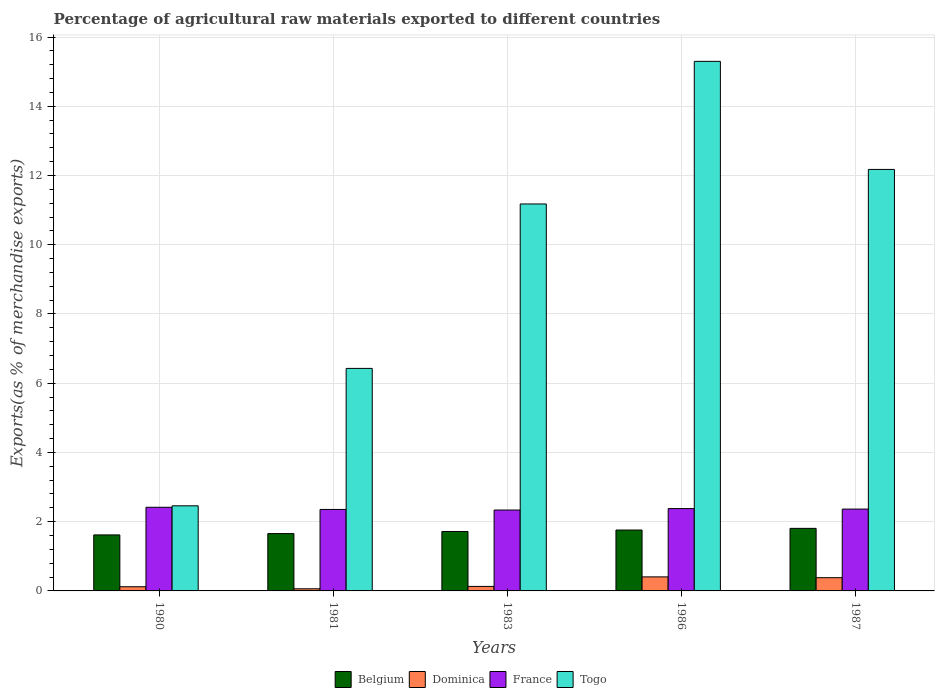How many different coloured bars are there?
Make the answer very short. 4. Are the number of bars per tick equal to the number of legend labels?
Offer a very short reply. Yes. How many bars are there on the 1st tick from the left?
Your response must be concise. 4. How many bars are there on the 3rd tick from the right?
Offer a very short reply. 4. What is the label of the 4th group of bars from the left?
Offer a very short reply. 1986. What is the percentage of exports to different countries in Belgium in 1983?
Your answer should be very brief. 1.72. Across all years, what is the maximum percentage of exports to different countries in Togo?
Keep it short and to the point. 15.3. Across all years, what is the minimum percentage of exports to different countries in Belgium?
Your answer should be very brief. 1.62. What is the total percentage of exports to different countries in France in the graph?
Keep it short and to the point. 11.85. What is the difference between the percentage of exports to different countries in Belgium in 1983 and that in 1987?
Offer a terse response. -0.09. What is the difference between the percentage of exports to different countries in France in 1981 and the percentage of exports to different countries in Belgium in 1987?
Keep it short and to the point. 0.55. What is the average percentage of exports to different countries in Belgium per year?
Make the answer very short. 1.71. In the year 1983, what is the difference between the percentage of exports to different countries in France and percentage of exports to different countries in Dominica?
Your answer should be very brief. 2.21. What is the ratio of the percentage of exports to different countries in Togo in 1980 to that in 1981?
Your answer should be compact. 0.38. What is the difference between the highest and the second highest percentage of exports to different countries in Dominica?
Your answer should be very brief. 0.02. What is the difference between the highest and the lowest percentage of exports to different countries in Togo?
Your answer should be very brief. 12.84. In how many years, is the percentage of exports to different countries in France greater than the average percentage of exports to different countries in France taken over all years?
Your answer should be very brief. 2. Is it the case that in every year, the sum of the percentage of exports to different countries in Togo and percentage of exports to different countries in Dominica is greater than the sum of percentage of exports to different countries in Belgium and percentage of exports to different countries in France?
Your response must be concise. Yes. What does the 4th bar from the left in 1986 represents?
Provide a short and direct response. Togo. How many bars are there?
Make the answer very short. 20. Are all the bars in the graph horizontal?
Offer a terse response. No. What is the difference between two consecutive major ticks on the Y-axis?
Provide a succinct answer. 2. Are the values on the major ticks of Y-axis written in scientific E-notation?
Offer a very short reply. No. Does the graph contain any zero values?
Ensure brevity in your answer.  No. Does the graph contain grids?
Make the answer very short. Yes. Where does the legend appear in the graph?
Keep it short and to the point. Bottom center. How are the legend labels stacked?
Provide a short and direct response. Horizontal. What is the title of the graph?
Your answer should be compact. Percentage of agricultural raw materials exported to different countries. Does "Other small states" appear as one of the legend labels in the graph?
Ensure brevity in your answer.  No. What is the label or title of the Y-axis?
Offer a terse response. Exports(as % of merchandise exports). What is the Exports(as % of merchandise exports) in Belgium in 1980?
Keep it short and to the point. 1.62. What is the Exports(as % of merchandise exports) of Dominica in 1980?
Offer a terse response. 0.12. What is the Exports(as % of merchandise exports) in France in 1980?
Your answer should be compact. 2.42. What is the Exports(as % of merchandise exports) in Togo in 1980?
Your answer should be compact. 2.46. What is the Exports(as % of merchandise exports) of Belgium in 1981?
Give a very brief answer. 1.66. What is the Exports(as % of merchandise exports) of Dominica in 1981?
Your response must be concise. 0.06. What is the Exports(as % of merchandise exports) of France in 1981?
Give a very brief answer. 2.35. What is the Exports(as % of merchandise exports) in Togo in 1981?
Ensure brevity in your answer.  6.43. What is the Exports(as % of merchandise exports) of Belgium in 1983?
Keep it short and to the point. 1.72. What is the Exports(as % of merchandise exports) of Dominica in 1983?
Make the answer very short. 0.13. What is the Exports(as % of merchandise exports) of France in 1983?
Your answer should be compact. 2.34. What is the Exports(as % of merchandise exports) in Togo in 1983?
Provide a succinct answer. 11.18. What is the Exports(as % of merchandise exports) in Belgium in 1986?
Your answer should be compact. 1.76. What is the Exports(as % of merchandise exports) in Dominica in 1986?
Make the answer very short. 0.41. What is the Exports(as % of merchandise exports) of France in 1986?
Your response must be concise. 2.38. What is the Exports(as % of merchandise exports) of Togo in 1986?
Offer a terse response. 15.3. What is the Exports(as % of merchandise exports) in Belgium in 1987?
Your answer should be very brief. 1.81. What is the Exports(as % of merchandise exports) in Dominica in 1987?
Your response must be concise. 0.38. What is the Exports(as % of merchandise exports) of France in 1987?
Your response must be concise. 2.36. What is the Exports(as % of merchandise exports) of Togo in 1987?
Make the answer very short. 12.18. Across all years, what is the maximum Exports(as % of merchandise exports) in Belgium?
Your answer should be compact. 1.81. Across all years, what is the maximum Exports(as % of merchandise exports) of Dominica?
Offer a terse response. 0.41. Across all years, what is the maximum Exports(as % of merchandise exports) in France?
Make the answer very short. 2.42. Across all years, what is the maximum Exports(as % of merchandise exports) in Togo?
Your response must be concise. 15.3. Across all years, what is the minimum Exports(as % of merchandise exports) in Belgium?
Give a very brief answer. 1.62. Across all years, what is the minimum Exports(as % of merchandise exports) of Dominica?
Your answer should be very brief. 0.06. Across all years, what is the minimum Exports(as % of merchandise exports) in France?
Your answer should be compact. 2.34. Across all years, what is the minimum Exports(as % of merchandise exports) of Togo?
Your answer should be compact. 2.46. What is the total Exports(as % of merchandise exports) of Belgium in the graph?
Provide a short and direct response. 8.56. What is the total Exports(as % of merchandise exports) in Dominica in the graph?
Keep it short and to the point. 1.1. What is the total Exports(as % of merchandise exports) in France in the graph?
Provide a succinct answer. 11.85. What is the total Exports(as % of merchandise exports) in Togo in the graph?
Make the answer very short. 47.54. What is the difference between the Exports(as % of merchandise exports) in Belgium in 1980 and that in 1981?
Make the answer very short. -0.04. What is the difference between the Exports(as % of merchandise exports) in Dominica in 1980 and that in 1981?
Offer a terse response. 0.06. What is the difference between the Exports(as % of merchandise exports) in France in 1980 and that in 1981?
Offer a very short reply. 0.06. What is the difference between the Exports(as % of merchandise exports) of Togo in 1980 and that in 1981?
Your answer should be compact. -3.97. What is the difference between the Exports(as % of merchandise exports) in Belgium in 1980 and that in 1983?
Give a very brief answer. -0.1. What is the difference between the Exports(as % of merchandise exports) of Dominica in 1980 and that in 1983?
Your answer should be compact. -0.01. What is the difference between the Exports(as % of merchandise exports) of Togo in 1980 and that in 1983?
Give a very brief answer. -8.72. What is the difference between the Exports(as % of merchandise exports) in Belgium in 1980 and that in 1986?
Ensure brevity in your answer.  -0.14. What is the difference between the Exports(as % of merchandise exports) of Dominica in 1980 and that in 1986?
Offer a very short reply. -0.29. What is the difference between the Exports(as % of merchandise exports) of France in 1980 and that in 1986?
Keep it short and to the point. 0.04. What is the difference between the Exports(as % of merchandise exports) of Togo in 1980 and that in 1986?
Ensure brevity in your answer.  -12.84. What is the difference between the Exports(as % of merchandise exports) of Belgium in 1980 and that in 1987?
Provide a succinct answer. -0.19. What is the difference between the Exports(as % of merchandise exports) of Dominica in 1980 and that in 1987?
Offer a terse response. -0.26. What is the difference between the Exports(as % of merchandise exports) of France in 1980 and that in 1987?
Provide a short and direct response. 0.05. What is the difference between the Exports(as % of merchandise exports) of Togo in 1980 and that in 1987?
Provide a succinct answer. -9.72. What is the difference between the Exports(as % of merchandise exports) of Belgium in 1981 and that in 1983?
Provide a short and direct response. -0.06. What is the difference between the Exports(as % of merchandise exports) of Dominica in 1981 and that in 1983?
Offer a terse response. -0.07. What is the difference between the Exports(as % of merchandise exports) of France in 1981 and that in 1983?
Offer a terse response. 0.02. What is the difference between the Exports(as % of merchandise exports) in Togo in 1981 and that in 1983?
Your answer should be compact. -4.75. What is the difference between the Exports(as % of merchandise exports) of Belgium in 1981 and that in 1986?
Ensure brevity in your answer.  -0.1. What is the difference between the Exports(as % of merchandise exports) of Dominica in 1981 and that in 1986?
Keep it short and to the point. -0.34. What is the difference between the Exports(as % of merchandise exports) of France in 1981 and that in 1986?
Ensure brevity in your answer.  -0.02. What is the difference between the Exports(as % of merchandise exports) of Togo in 1981 and that in 1986?
Provide a succinct answer. -8.87. What is the difference between the Exports(as % of merchandise exports) in Belgium in 1981 and that in 1987?
Provide a short and direct response. -0.15. What is the difference between the Exports(as % of merchandise exports) in Dominica in 1981 and that in 1987?
Your answer should be compact. -0.32. What is the difference between the Exports(as % of merchandise exports) of France in 1981 and that in 1987?
Offer a very short reply. -0.01. What is the difference between the Exports(as % of merchandise exports) in Togo in 1981 and that in 1987?
Make the answer very short. -5.75. What is the difference between the Exports(as % of merchandise exports) of Belgium in 1983 and that in 1986?
Keep it short and to the point. -0.04. What is the difference between the Exports(as % of merchandise exports) in Dominica in 1983 and that in 1986?
Provide a succinct answer. -0.28. What is the difference between the Exports(as % of merchandise exports) of France in 1983 and that in 1986?
Make the answer very short. -0.04. What is the difference between the Exports(as % of merchandise exports) in Togo in 1983 and that in 1986?
Offer a terse response. -4.12. What is the difference between the Exports(as % of merchandise exports) in Belgium in 1983 and that in 1987?
Offer a very short reply. -0.09. What is the difference between the Exports(as % of merchandise exports) of Dominica in 1983 and that in 1987?
Provide a short and direct response. -0.25. What is the difference between the Exports(as % of merchandise exports) in France in 1983 and that in 1987?
Give a very brief answer. -0.03. What is the difference between the Exports(as % of merchandise exports) of Togo in 1983 and that in 1987?
Your answer should be compact. -1. What is the difference between the Exports(as % of merchandise exports) in Belgium in 1986 and that in 1987?
Offer a very short reply. -0.05. What is the difference between the Exports(as % of merchandise exports) of Dominica in 1986 and that in 1987?
Offer a very short reply. 0.02. What is the difference between the Exports(as % of merchandise exports) in France in 1986 and that in 1987?
Ensure brevity in your answer.  0.01. What is the difference between the Exports(as % of merchandise exports) in Togo in 1986 and that in 1987?
Offer a terse response. 3.12. What is the difference between the Exports(as % of merchandise exports) of Belgium in 1980 and the Exports(as % of merchandise exports) of Dominica in 1981?
Your response must be concise. 1.56. What is the difference between the Exports(as % of merchandise exports) in Belgium in 1980 and the Exports(as % of merchandise exports) in France in 1981?
Ensure brevity in your answer.  -0.74. What is the difference between the Exports(as % of merchandise exports) in Belgium in 1980 and the Exports(as % of merchandise exports) in Togo in 1981?
Offer a very short reply. -4.81. What is the difference between the Exports(as % of merchandise exports) in Dominica in 1980 and the Exports(as % of merchandise exports) in France in 1981?
Your response must be concise. -2.23. What is the difference between the Exports(as % of merchandise exports) in Dominica in 1980 and the Exports(as % of merchandise exports) in Togo in 1981?
Your response must be concise. -6.31. What is the difference between the Exports(as % of merchandise exports) in France in 1980 and the Exports(as % of merchandise exports) in Togo in 1981?
Ensure brevity in your answer.  -4.01. What is the difference between the Exports(as % of merchandise exports) of Belgium in 1980 and the Exports(as % of merchandise exports) of Dominica in 1983?
Provide a succinct answer. 1.49. What is the difference between the Exports(as % of merchandise exports) of Belgium in 1980 and the Exports(as % of merchandise exports) of France in 1983?
Make the answer very short. -0.72. What is the difference between the Exports(as % of merchandise exports) in Belgium in 1980 and the Exports(as % of merchandise exports) in Togo in 1983?
Give a very brief answer. -9.56. What is the difference between the Exports(as % of merchandise exports) in Dominica in 1980 and the Exports(as % of merchandise exports) in France in 1983?
Ensure brevity in your answer.  -2.22. What is the difference between the Exports(as % of merchandise exports) in Dominica in 1980 and the Exports(as % of merchandise exports) in Togo in 1983?
Your answer should be very brief. -11.06. What is the difference between the Exports(as % of merchandise exports) in France in 1980 and the Exports(as % of merchandise exports) in Togo in 1983?
Your response must be concise. -8.76. What is the difference between the Exports(as % of merchandise exports) in Belgium in 1980 and the Exports(as % of merchandise exports) in Dominica in 1986?
Provide a succinct answer. 1.21. What is the difference between the Exports(as % of merchandise exports) in Belgium in 1980 and the Exports(as % of merchandise exports) in France in 1986?
Keep it short and to the point. -0.76. What is the difference between the Exports(as % of merchandise exports) in Belgium in 1980 and the Exports(as % of merchandise exports) in Togo in 1986?
Your answer should be very brief. -13.68. What is the difference between the Exports(as % of merchandise exports) in Dominica in 1980 and the Exports(as % of merchandise exports) in France in 1986?
Your response must be concise. -2.26. What is the difference between the Exports(as % of merchandise exports) of Dominica in 1980 and the Exports(as % of merchandise exports) of Togo in 1986?
Make the answer very short. -15.18. What is the difference between the Exports(as % of merchandise exports) of France in 1980 and the Exports(as % of merchandise exports) of Togo in 1986?
Offer a very short reply. -12.88. What is the difference between the Exports(as % of merchandise exports) of Belgium in 1980 and the Exports(as % of merchandise exports) of Dominica in 1987?
Keep it short and to the point. 1.24. What is the difference between the Exports(as % of merchandise exports) in Belgium in 1980 and the Exports(as % of merchandise exports) in France in 1987?
Ensure brevity in your answer.  -0.75. What is the difference between the Exports(as % of merchandise exports) in Belgium in 1980 and the Exports(as % of merchandise exports) in Togo in 1987?
Ensure brevity in your answer.  -10.56. What is the difference between the Exports(as % of merchandise exports) of Dominica in 1980 and the Exports(as % of merchandise exports) of France in 1987?
Give a very brief answer. -2.24. What is the difference between the Exports(as % of merchandise exports) of Dominica in 1980 and the Exports(as % of merchandise exports) of Togo in 1987?
Your answer should be compact. -12.05. What is the difference between the Exports(as % of merchandise exports) in France in 1980 and the Exports(as % of merchandise exports) in Togo in 1987?
Keep it short and to the point. -9.76. What is the difference between the Exports(as % of merchandise exports) in Belgium in 1981 and the Exports(as % of merchandise exports) in Dominica in 1983?
Provide a short and direct response. 1.53. What is the difference between the Exports(as % of merchandise exports) in Belgium in 1981 and the Exports(as % of merchandise exports) in France in 1983?
Offer a terse response. -0.68. What is the difference between the Exports(as % of merchandise exports) in Belgium in 1981 and the Exports(as % of merchandise exports) in Togo in 1983?
Offer a very short reply. -9.52. What is the difference between the Exports(as % of merchandise exports) in Dominica in 1981 and the Exports(as % of merchandise exports) in France in 1983?
Your answer should be compact. -2.28. What is the difference between the Exports(as % of merchandise exports) in Dominica in 1981 and the Exports(as % of merchandise exports) in Togo in 1983?
Offer a terse response. -11.12. What is the difference between the Exports(as % of merchandise exports) of France in 1981 and the Exports(as % of merchandise exports) of Togo in 1983?
Provide a succinct answer. -8.82. What is the difference between the Exports(as % of merchandise exports) of Belgium in 1981 and the Exports(as % of merchandise exports) of Dominica in 1986?
Give a very brief answer. 1.25. What is the difference between the Exports(as % of merchandise exports) in Belgium in 1981 and the Exports(as % of merchandise exports) in France in 1986?
Make the answer very short. -0.72. What is the difference between the Exports(as % of merchandise exports) of Belgium in 1981 and the Exports(as % of merchandise exports) of Togo in 1986?
Give a very brief answer. -13.64. What is the difference between the Exports(as % of merchandise exports) in Dominica in 1981 and the Exports(as % of merchandise exports) in France in 1986?
Keep it short and to the point. -2.32. What is the difference between the Exports(as % of merchandise exports) in Dominica in 1981 and the Exports(as % of merchandise exports) in Togo in 1986?
Provide a short and direct response. -15.24. What is the difference between the Exports(as % of merchandise exports) of France in 1981 and the Exports(as % of merchandise exports) of Togo in 1986?
Ensure brevity in your answer.  -12.94. What is the difference between the Exports(as % of merchandise exports) in Belgium in 1981 and the Exports(as % of merchandise exports) in Dominica in 1987?
Offer a terse response. 1.27. What is the difference between the Exports(as % of merchandise exports) of Belgium in 1981 and the Exports(as % of merchandise exports) of France in 1987?
Your response must be concise. -0.71. What is the difference between the Exports(as % of merchandise exports) of Belgium in 1981 and the Exports(as % of merchandise exports) of Togo in 1987?
Give a very brief answer. -10.52. What is the difference between the Exports(as % of merchandise exports) of Dominica in 1981 and the Exports(as % of merchandise exports) of France in 1987?
Your response must be concise. -2.3. What is the difference between the Exports(as % of merchandise exports) of Dominica in 1981 and the Exports(as % of merchandise exports) of Togo in 1987?
Keep it short and to the point. -12.11. What is the difference between the Exports(as % of merchandise exports) of France in 1981 and the Exports(as % of merchandise exports) of Togo in 1987?
Provide a short and direct response. -9.82. What is the difference between the Exports(as % of merchandise exports) in Belgium in 1983 and the Exports(as % of merchandise exports) in Dominica in 1986?
Make the answer very short. 1.31. What is the difference between the Exports(as % of merchandise exports) in Belgium in 1983 and the Exports(as % of merchandise exports) in France in 1986?
Provide a short and direct response. -0.66. What is the difference between the Exports(as % of merchandise exports) of Belgium in 1983 and the Exports(as % of merchandise exports) of Togo in 1986?
Your answer should be very brief. -13.58. What is the difference between the Exports(as % of merchandise exports) in Dominica in 1983 and the Exports(as % of merchandise exports) in France in 1986?
Make the answer very short. -2.25. What is the difference between the Exports(as % of merchandise exports) in Dominica in 1983 and the Exports(as % of merchandise exports) in Togo in 1986?
Offer a very short reply. -15.17. What is the difference between the Exports(as % of merchandise exports) in France in 1983 and the Exports(as % of merchandise exports) in Togo in 1986?
Keep it short and to the point. -12.96. What is the difference between the Exports(as % of merchandise exports) in Belgium in 1983 and the Exports(as % of merchandise exports) in Dominica in 1987?
Offer a terse response. 1.33. What is the difference between the Exports(as % of merchandise exports) in Belgium in 1983 and the Exports(as % of merchandise exports) in France in 1987?
Keep it short and to the point. -0.65. What is the difference between the Exports(as % of merchandise exports) in Belgium in 1983 and the Exports(as % of merchandise exports) in Togo in 1987?
Your answer should be compact. -10.46. What is the difference between the Exports(as % of merchandise exports) of Dominica in 1983 and the Exports(as % of merchandise exports) of France in 1987?
Give a very brief answer. -2.23. What is the difference between the Exports(as % of merchandise exports) in Dominica in 1983 and the Exports(as % of merchandise exports) in Togo in 1987?
Give a very brief answer. -12.05. What is the difference between the Exports(as % of merchandise exports) of France in 1983 and the Exports(as % of merchandise exports) of Togo in 1987?
Your answer should be very brief. -9.84. What is the difference between the Exports(as % of merchandise exports) in Belgium in 1986 and the Exports(as % of merchandise exports) in Dominica in 1987?
Offer a terse response. 1.38. What is the difference between the Exports(as % of merchandise exports) in Belgium in 1986 and the Exports(as % of merchandise exports) in France in 1987?
Keep it short and to the point. -0.61. What is the difference between the Exports(as % of merchandise exports) of Belgium in 1986 and the Exports(as % of merchandise exports) of Togo in 1987?
Your answer should be very brief. -10.42. What is the difference between the Exports(as % of merchandise exports) in Dominica in 1986 and the Exports(as % of merchandise exports) in France in 1987?
Ensure brevity in your answer.  -1.96. What is the difference between the Exports(as % of merchandise exports) of Dominica in 1986 and the Exports(as % of merchandise exports) of Togo in 1987?
Give a very brief answer. -11.77. What is the difference between the Exports(as % of merchandise exports) of France in 1986 and the Exports(as % of merchandise exports) of Togo in 1987?
Offer a very short reply. -9.8. What is the average Exports(as % of merchandise exports) in Belgium per year?
Keep it short and to the point. 1.71. What is the average Exports(as % of merchandise exports) of Dominica per year?
Make the answer very short. 0.22. What is the average Exports(as % of merchandise exports) of France per year?
Keep it short and to the point. 2.37. What is the average Exports(as % of merchandise exports) in Togo per year?
Offer a terse response. 9.51. In the year 1980, what is the difference between the Exports(as % of merchandise exports) in Belgium and Exports(as % of merchandise exports) in Dominica?
Make the answer very short. 1.5. In the year 1980, what is the difference between the Exports(as % of merchandise exports) of Belgium and Exports(as % of merchandise exports) of France?
Offer a very short reply. -0.8. In the year 1980, what is the difference between the Exports(as % of merchandise exports) in Belgium and Exports(as % of merchandise exports) in Togo?
Your response must be concise. -0.84. In the year 1980, what is the difference between the Exports(as % of merchandise exports) of Dominica and Exports(as % of merchandise exports) of France?
Provide a short and direct response. -2.3. In the year 1980, what is the difference between the Exports(as % of merchandise exports) in Dominica and Exports(as % of merchandise exports) in Togo?
Keep it short and to the point. -2.34. In the year 1980, what is the difference between the Exports(as % of merchandise exports) in France and Exports(as % of merchandise exports) in Togo?
Offer a very short reply. -0.04. In the year 1981, what is the difference between the Exports(as % of merchandise exports) in Belgium and Exports(as % of merchandise exports) in Dominica?
Keep it short and to the point. 1.59. In the year 1981, what is the difference between the Exports(as % of merchandise exports) of Belgium and Exports(as % of merchandise exports) of France?
Offer a very short reply. -0.7. In the year 1981, what is the difference between the Exports(as % of merchandise exports) of Belgium and Exports(as % of merchandise exports) of Togo?
Make the answer very short. -4.77. In the year 1981, what is the difference between the Exports(as % of merchandise exports) in Dominica and Exports(as % of merchandise exports) in France?
Your answer should be very brief. -2.29. In the year 1981, what is the difference between the Exports(as % of merchandise exports) in Dominica and Exports(as % of merchandise exports) in Togo?
Your response must be concise. -6.37. In the year 1981, what is the difference between the Exports(as % of merchandise exports) of France and Exports(as % of merchandise exports) of Togo?
Provide a short and direct response. -4.07. In the year 1983, what is the difference between the Exports(as % of merchandise exports) in Belgium and Exports(as % of merchandise exports) in Dominica?
Provide a succinct answer. 1.59. In the year 1983, what is the difference between the Exports(as % of merchandise exports) of Belgium and Exports(as % of merchandise exports) of France?
Offer a very short reply. -0.62. In the year 1983, what is the difference between the Exports(as % of merchandise exports) of Belgium and Exports(as % of merchandise exports) of Togo?
Offer a very short reply. -9.46. In the year 1983, what is the difference between the Exports(as % of merchandise exports) in Dominica and Exports(as % of merchandise exports) in France?
Provide a succinct answer. -2.21. In the year 1983, what is the difference between the Exports(as % of merchandise exports) in Dominica and Exports(as % of merchandise exports) in Togo?
Offer a terse response. -11.05. In the year 1983, what is the difference between the Exports(as % of merchandise exports) in France and Exports(as % of merchandise exports) in Togo?
Make the answer very short. -8.84. In the year 1986, what is the difference between the Exports(as % of merchandise exports) in Belgium and Exports(as % of merchandise exports) in Dominica?
Provide a short and direct response. 1.35. In the year 1986, what is the difference between the Exports(as % of merchandise exports) of Belgium and Exports(as % of merchandise exports) of France?
Provide a succinct answer. -0.62. In the year 1986, what is the difference between the Exports(as % of merchandise exports) in Belgium and Exports(as % of merchandise exports) in Togo?
Provide a short and direct response. -13.54. In the year 1986, what is the difference between the Exports(as % of merchandise exports) of Dominica and Exports(as % of merchandise exports) of France?
Your response must be concise. -1.97. In the year 1986, what is the difference between the Exports(as % of merchandise exports) in Dominica and Exports(as % of merchandise exports) in Togo?
Offer a very short reply. -14.89. In the year 1986, what is the difference between the Exports(as % of merchandise exports) of France and Exports(as % of merchandise exports) of Togo?
Ensure brevity in your answer.  -12.92. In the year 1987, what is the difference between the Exports(as % of merchandise exports) of Belgium and Exports(as % of merchandise exports) of Dominica?
Provide a succinct answer. 1.43. In the year 1987, what is the difference between the Exports(as % of merchandise exports) in Belgium and Exports(as % of merchandise exports) in France?
Provide a succinct answer. -0.56. In the year 1987, what is the difference between the Exports(as % of merchandise exports) of Belgium and Exports(as % of merchandise exports) of Togo?
Your answer should be compact. -10.37. In the year 1987, what is the difference between the Exports(as % of merchandise exports) of Dominica and Exports(as % of merchandise exports) of France?
Give a very brief answer. -1.98. In the year 1987, what is the difference between the Exports(as % of merchandise exports) of Dominica and Exports(as % of merchandise exports) of Togo?
Your answer should be very brief. -11.79. In the year 1987, what is the difference between the Exports(as % of merchandise exports) of France and Exports(as % of merchandise exports) of Togo?
Your answer should be compact. -9.81. What is the ratio of the Exports(as % of merchandise exports) of Belgium in 1980 to that in 1981?
Give a very brief answer. 0.98. What is the ratio of the Exports(as % of merchandise exports) in Dominica in 1980 to that in 1981?
Provide a short and direct response. 1.96. What is the ratio of the Exports(as % of merchandise exports) of France in 1980 to that in 1981?
Your response must be concise. 1.03. What is the ratio of the Exports(as % of merchandise exports) of Togo in 1980 to that in 1981?
Make the answer very short. 0.38. What is the ratio of the Exports(as % of merchandise exports) in Belgium in 1980 to that in 1983?
Offer a terse response. 0.94. What is the ratio of the Exports(as % of merchandise exports) of Dominica in 1980 to that in 1983?
Provide a short and direct response. 0.93. What is the ratio of the Exports(as % of merchandise exports) of France in 1980 to that in 1983?
Make the answer very short. 1.03. What is the ratio of the Exports(as % of merchandise exports) of Togo in 1980 to that in 1983?
Give a very brief answer. 0.22. What is the ratio of the Exports(as % of merchandise exports) of Belgium in 1980 to that in 1986?
Your response must be concise. 0.92. What is the ratio of the Exports(as % of merchandise exports) in Dominica in 1980 to that in 1986?
Give a very brief answer. 0.3. What is the ratio of the Exports(as % of merchandise exports) of France in 1980 to that in 1986?
Ensure brevity in your answer.  1.02. What is the ratio of the Exports(as % of merchandise exports) in Togo in 1980 to that in 1986?
Your answer should be compact. 0.16. What is the ratio of the Exports(as % of merchandise exports) in Belgium in 1980 to that in 1987?
Offer a terse response. 0.9. What is the ratio of the Exports(as % of merchandise exports) of Dominica in 1980 to that in 1987?
Offer a terse response. 0.32. What is the ratio of the Exports(as % of merchandise exports) in France in 1980 to that in 1987?
Ensure brevity in your answer.  1.02. What is the ratio of the Exports(as % of merchandise exports) of Togo in 1980 to that in 1987?
Ensure brevity in your answer.  0.2. What is the ratio of the Exports(as % of merchandise exports) of Belgium in 1981 to that in 1983?
Ensure brevity in your answer.  0.96. What is the ratio of the Exports(as % of merchandise exports) in Dominica in 1981 to that in 1983?
Your answer should be compact. 0.47. What is the ratio of the Exports(as % of merchandise exports) in France in 1981 to that in 1983?
Give a very brief answer. 1.01. What is the ratio of the Exports(as % of merchandise exports) of Togo in 1981 to that in 1983?
Ensure brevity in your answer.  0.58. What is the ratio of the Exports(as % of merchandise exports) in Belgium in 1981 to that in 1986?
Ensure brevity in your answer.  0.94. What is the ratio of the Exports(as % of merchandise exports) in Dominica in 1981 to that in 1986?
Offer a very short reply. 0.15. What is the ratio of the Exports(as % of merchandise exports) of France in 1981 to that in 1986?
Give a very brief answer. 0.99. What is the ratio of the Exports(as % of merchandise exports) in Togo in 1981 to that in 1986?
Provide a short and direct response. 0.42. What is the ratio of the Exports(as % of merchandise exports) of Belgium in 1981 to that in 1987?
Your answer should be very brief. 0.92. What is the ratio of the Exports(as % of merchandise exports) of Dominica in 1981 to that in 1987?
Provide a succinct answer. 0.16. What is the ratio of the Exports(as % of merchandise exports) of France in 1981 to that in 1987?
Ensure brevity in your answer.  1. What is the ratio of the Exports(as % of merchandise exports) of Togo in 1981 to that in 1987?
Your answer should be very brief. 0.53. What is the ratio of the Exports(as % of merchandise exports) in Belgium in 1983 to that in 1986?
Make the answer very short. 0.98. What is the ratio of the Exports(as % of merchandise exports) of Dominica in 1983 to that in 1986?
Offer a very short reply. 0.32. What is the ratio of the Exports(as % of merchandise exports) of France in 1983 to that in 1986?
Your answer should be very brief. 0.98. What is the ratio of the Exports(as % of merchandise exports) in Togo in 1983 to that in 1986?
Keep it short and to the point. 0.73. What is the ratio of the Exports(as % of merchandise exports) in Dominica in 1983 to that in 1987?
Your answer should be very brief. 0.34. What is the ratio of the Exports(as % of merchandise exports) in France in 1983 to that in 1987?
Make the answer very short. 0.99. What is the ratio of the Exports(as % of merchandise exports) in Togo in 1983 to that in 1987?
Your answer should be very brief. 0.92. What is the ratio of the Exports(as % of merchandise exports) of Belgium in 1986 to that in 1987?
Give a very brief answer. 0.97. What is the ratio of the Exports(as % of merchandise exports) in Dominica in 1986 to that in 1987?
Ensure brevity in your answer.  1.06. What is the ratio of the Exports(as % of merchandise exports) of Togo in 1986 to that in 1987?
Offer a very short reply. 1.26. What is the difference between the highest and the second highest Exports(as % of merchandise exports) of Belgium?
Offer a terse response. 0.05. What is the difference between the highest and the second highest Exports(as % of merchandise exports) of Dominica?
Offer a terse response. 0.02. What is the difference between the highest and the second highest Exports(as % of merchandise exports) of France?
Provide a succinct answer. 0.04. What is the difference between the highest and the second highest Exports(as % of merchandise exports) in Togo?
Ensure brevity in your answer.  3.12. What is the difference between the highest and the lowest Exports(as % of merchandise exports) in Belgium?
Give a very brief answer. 0.19. What is the difference between the highest and the lowest Exports(as % of merchandise exports) of Dominica?
Make the answer very short. 0.34. What is the difference between the highest and the lowest Exports(as % of merchandise exports) of Togo?
Make the answer very short. 12.84. 